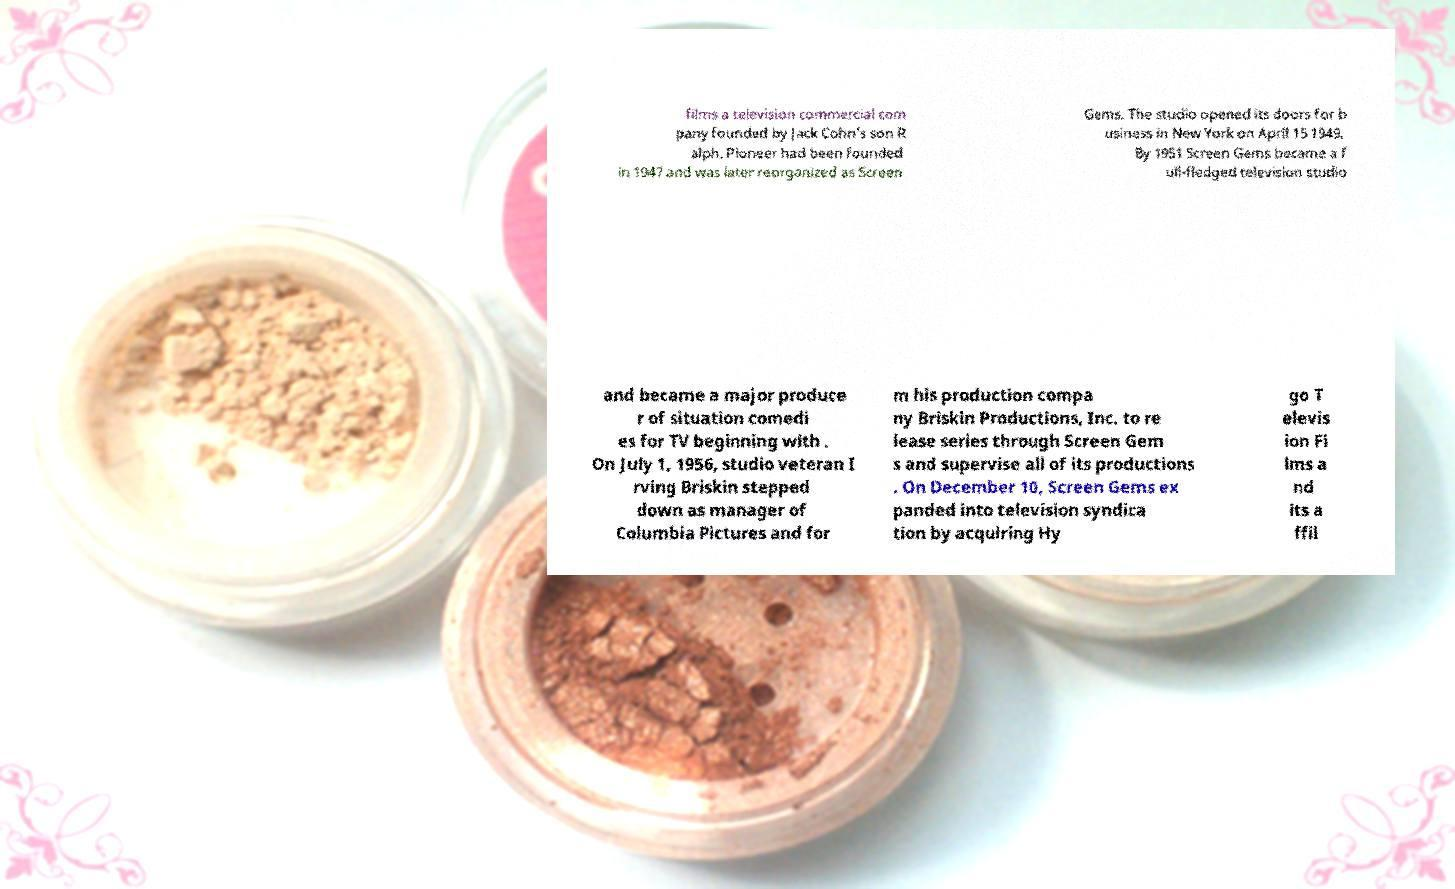Could you assist in decoding the text presented in this image and type it out clearly? films a television commercial com pany founded by Jack Cohn's son R alph. Pioneer had been founded in 1947 and was later reorganized as Screen Gems. The studio opened its doors for b usiness in New York on April 15 1949. By 1951 Screen Gems became a f ull-fledged television studio and became a major produce r of situation comedi es for TV beginning with . On July 1, 1956, studio veteran I rving Briskin stepped down as manager of Columbia Pictures and for m his production compa ny Briskin Productions, Inc. to re lease series through Screen Gem s and supervise all of its productions . On December 10, Screen Gems ex panded into television syndica tion by acquiring Hy go T elevis ion Fi lms a nd its a ffil 